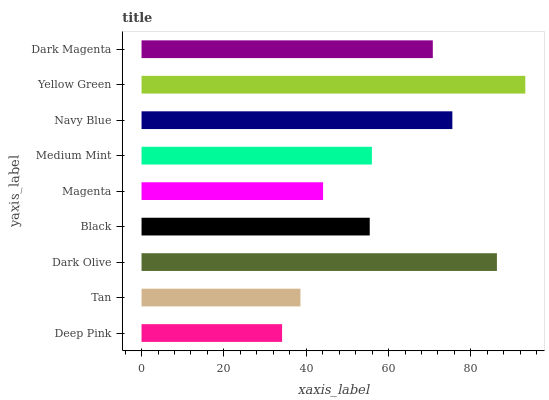Is Deep Pink the minimum?
Answer yes or no. Yes. Is Yellow Green the maximum?
Answer yes or no. Yes. Is Tan the minimum?
Answer yes or no. No. Is Tan the maximum?
Answer yes or no. No. Is Tan greater than Deep Pink?
Answer yes or no. Yes. Is Deep Pink less than Tan?
Answer yes or no. Yes. Is Deep Pink greater than Tan?
Answer yes or no. No. Is Tan less than Deep Pink?
Answer yes or no. No. Is Medium Mint the high median?
Answer yes or no. Yes. Is Medium Mint the low median?
Answer yes or no. Yes. Is Black the high median?
Answer yes or no. No. Is Black the low median?
Answer yes or no. No. 